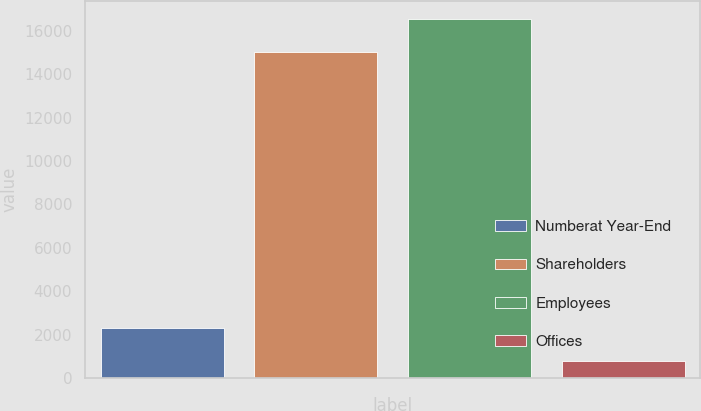<chart> <loc_0><loc_0><loc_500><loc_500><bar_chart><fcel>Numberat Year-End<fcel>Shareholders<fcel>Employees<fcel>Offices<nl><fcel>2305.7<fcel>15015<fcel>16524.7<fcel>796<nl></chart> 